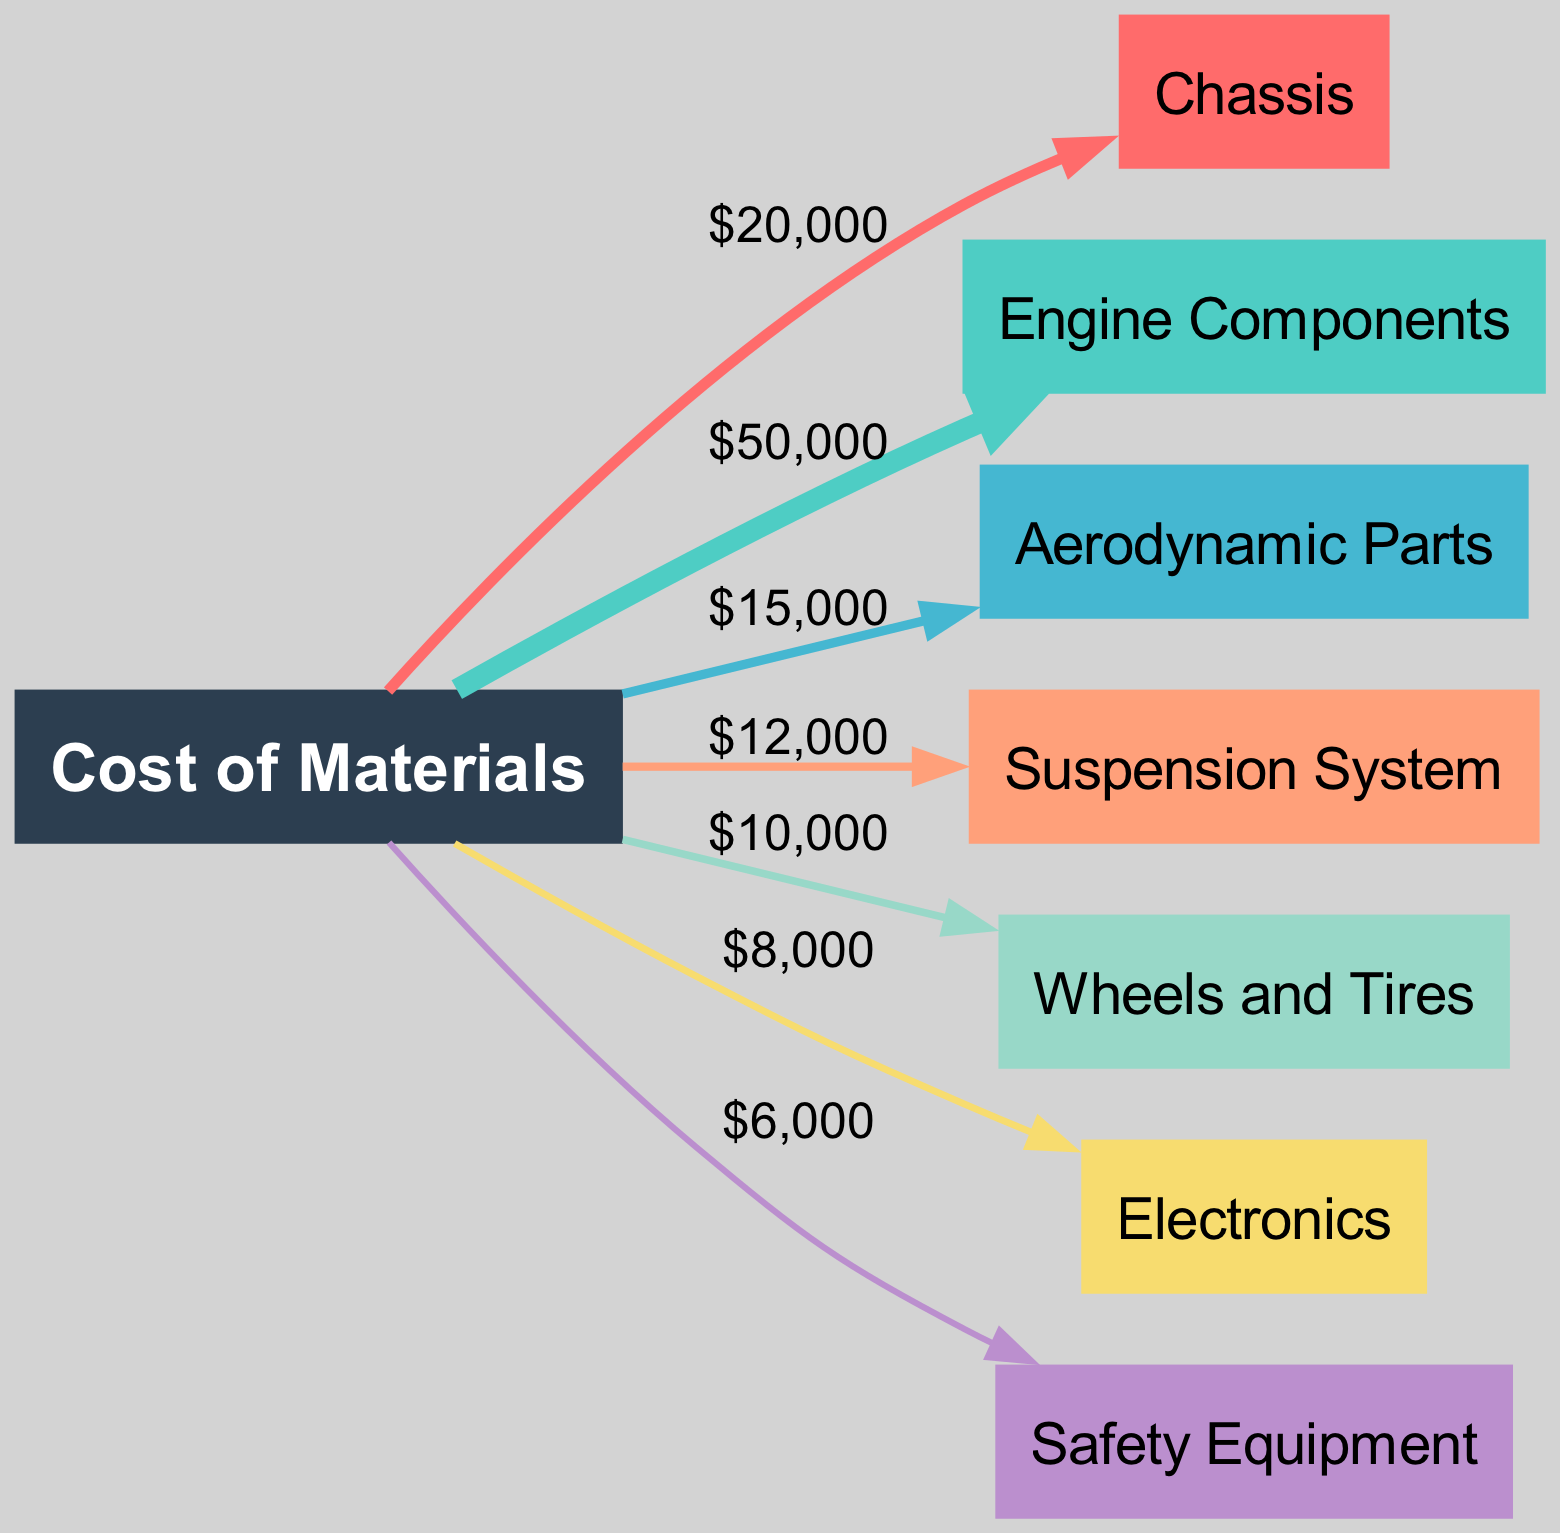What is the total budget for materials in race car build? The total budget can be found by summing all the values flowing from the "Cost of Materials" node to each of its connected nodes (Chassis, Engine Components, Aerodynamic Parts, etc.). Adding these values gives us: 20000 + 50000 + 15000 + 12000 + 10000 + 8000 + 6000 = 130000.
Answer: 130000 Which category has the highest budget allocation? To find the category with the highest budget allocation, compare the values of each link emanating from the "Cost of Materials" node. The "Engine Components" node has the value of 50000, which is greater than any other category.
Answer: Engine Components What is the budget allocated to Safety Equipment? The budget for "Safety Equipment" is indicated by the link from "Cost of Materials" to "Safety Equipment," which carries the value of 6000.
Answer: 6000 How many major expense categories are represented in this diagram? The number of nodes connected to the "Cost of Materials" node represents the major expense categories. There are 7 categories: Chassis, Engine Components, Aerodynamic Parts, Suspension System, Wheels and Tires, Electronics, and Safety Equipment.
Answer: 7 What is the budget allocation for Aerodynamic Parts compared to Suspension System? The allocation for "Aerodynamic Parts" is 15000, while for "Suspension System" it is 12000. Comparing these values shows that "Aerodynamic Parts" has a higher allocation.
Answer: Aerodynamic Parts What percentage of the total budget is spent on Wheels and Tires? The budget for "Wheels and Tires" is 10000. To find the percentage of the total budget (130000), calculate (10000 / 130000) * 100, which gives approximately 7.69%.
Answer: 7.69% Which two categories have the lowest budget allocations? Look at the link values from "Cost of Materials" to identify the lowest allocations. "Electronics" (8000) and "Safety Equipment" (6000) have the smallest values among all categories.
Answer: Electronics, Safety Equipment What is the combined budget allocation for Chassis and Aerodynamic Parts? To find the combined budget allocation for these two categories, add their respective values: Chassis (20000) + Aerodynamic Parts (15000) = 35000.
Answer: 35000 